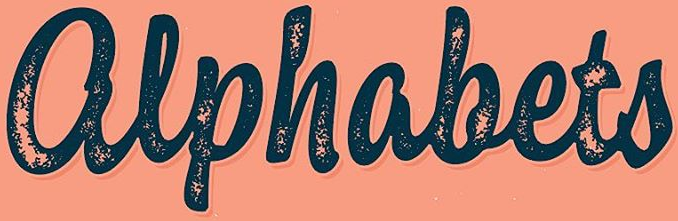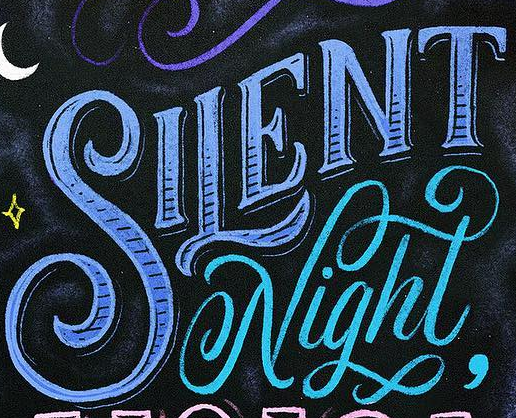What text appears in these images from left to right, separated by a semicolon? alphabets; SILENT 